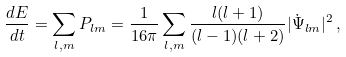Convert formula to latex. <formula><loc_0><loc_0><loc_500><loc_500>\frac { d E } { d t } = \sum _ { l , m } P _ { l m } = \frac { 1 } { 1 6 \pi } \sum _ { l , m } \frac { l ( l + 1 ) } { ( l - 1 ) ( l + 2 ) } | \dot { \Psi } _ { l m } | ^ { 2 } \, ,</formula> 